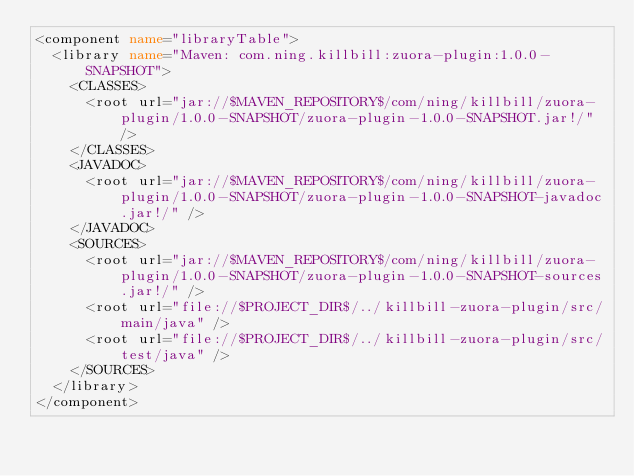<code> <loc_0><loc_0><loc_500><loc_500><_XML_><component name="libraryTable">
  <library name="Maven: com.ning.killbill:zuora-plugin:1.0.0-SNAPSHOT">
    <CLASSES>
      <root url="jar://$MAVEN_REPOSITORY$/com/ning/killbill/zuora-plugin/1.0.0-SNAPSHOT/zuora-plugin-1.0.0-SNAPSHOT.jar!/" />
    </CLASSES>
    <JAVADOC>
      <root url="jar://$MAVEN_REPOSITORY$/com/ning/killbill/zuora-plugin/1.0.0-SNAPSHOT/zuora-plugin-1.0.0-SNAPSHOT-javadoc.jar!/" />
    </JAVADOC>
    <SOURCES>
      <root url="jar://$MAVEN_REPOSITORY$/com/ning/killbill/zuora-plugin/1.0.0-SNAPSHOT/zuora-plugin-1.0.0-SNAPSHOT-sources.jar!/" />
      <root url="file://$PROJECT_DIR$/../killbill-zuora-plugin/src/main/java" />
      <root url="file://$PROJECT_DIR$/../killbill-zuora-plugin/src/test/java" />
    </SOURCES>
  </library>
</component></code> 